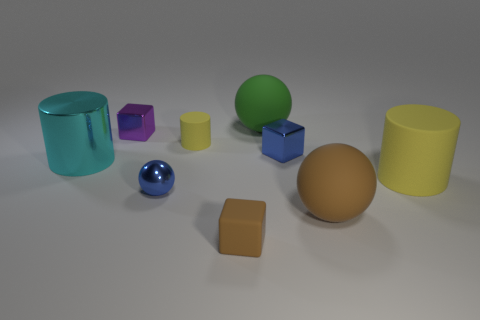Subtract all small shiny cubes. How many cubes are left? 1 Subtract all spheres. How many objects are left? 6 Add 2 tiny blue shiny balls. How many tiny blue shiny balls exist? 3 Subtract 0 cyan cubes. How many objects are left? 9 Subtract all yellow things. Subtract all tiny cyan shiny objects. How many objects are left? 7 Add 9 small matte cylinders. How many small matte cylinders are left? 10 